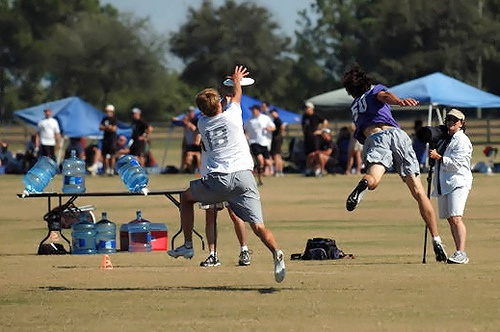Describe the objects in this image and their specific colors. I can see people in black, white, gray, and darkgray tones, people in black, lightgray, darkgray, and gray tones, people in black, white, gray, and darkgray tones, people in black, lightgray, darkgray, and gray tones, and people in black, lightgray, gray, and darkgray tones in this image. 